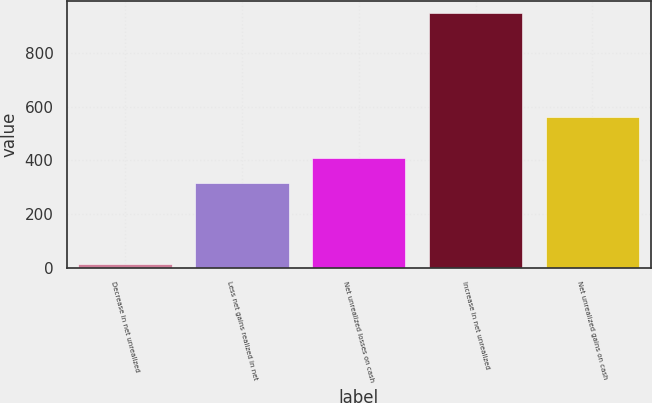Convert chart to OTSL. <chart><loc_0><loc_0><loc_500><loc_500><bar_chart><fcel>Decrease in net unrealized<fcel>Less net gains realized in net<fcel>Net unrealized losses on cash<fcel>Increase in net unrealized<fcel>Net unrealized gains on cash<nl><fcel>12<fcel>317<fcel>410.6<fcel>948<fcel>561<nl></chart> 